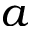Convert formula to latex. <formula><loc_0><loc_0><loc_500><loc_500>a</formula> 